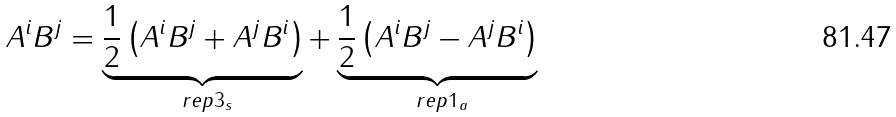<formula> <loc_0><loc_0><loc_500><loc_500>A ^ { i } B ^ { j } = \underbrace { \frac { 1 } { 2 } \left ( A ^ { i } B ^ { j } + A ^ { j } B ^ { i } \right ) } _ { \ r e p { 3 } _ { s } } + \underbrace { \frac { 1 } { 2 } \left ( A ^ { i } B ^ { j } - A ^ { j } B ^ { i } \right ) } _ { \ r e p { 1 } _ { a } }</formula> 